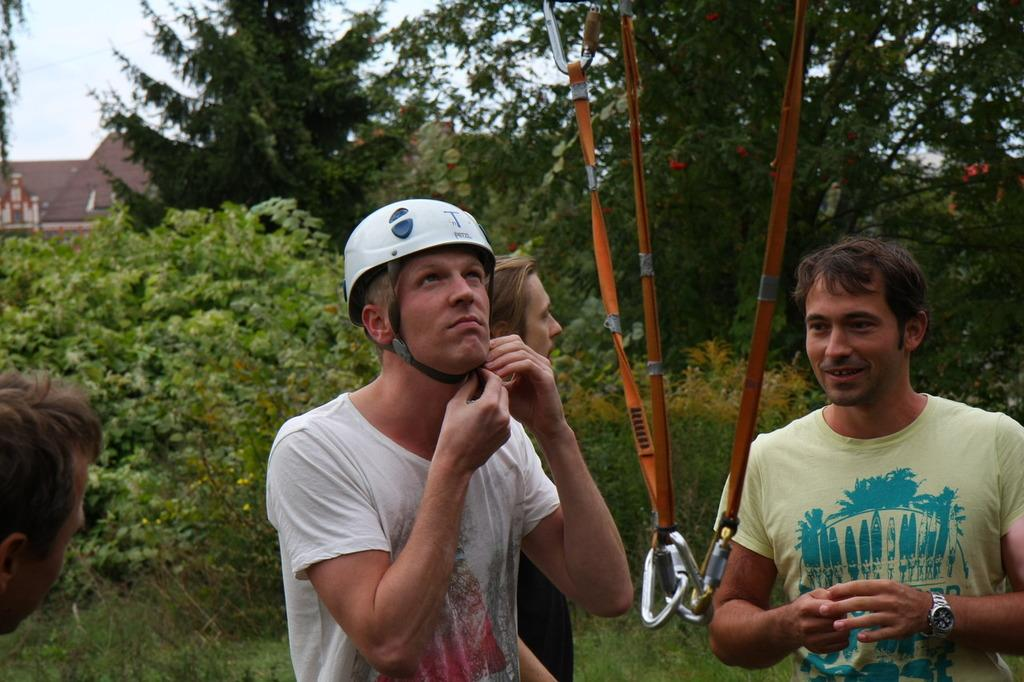What are the men in the image doing? The men in the image are standing on the ground. What objects are connected to the hooks in the image? Ropes are tied to the hooks in the image. What type of vegetation can be seen in the image? Plants, grass, and trees are present in the image. What structures are visible in the image? Buildings are visible in the image. What part of the natural environment is visible in the image? The sky is visible in the image. What type of shock can be seen in the image? There is no shock present in the image. What type of root is visible in the image? There is no root visible in the image. 